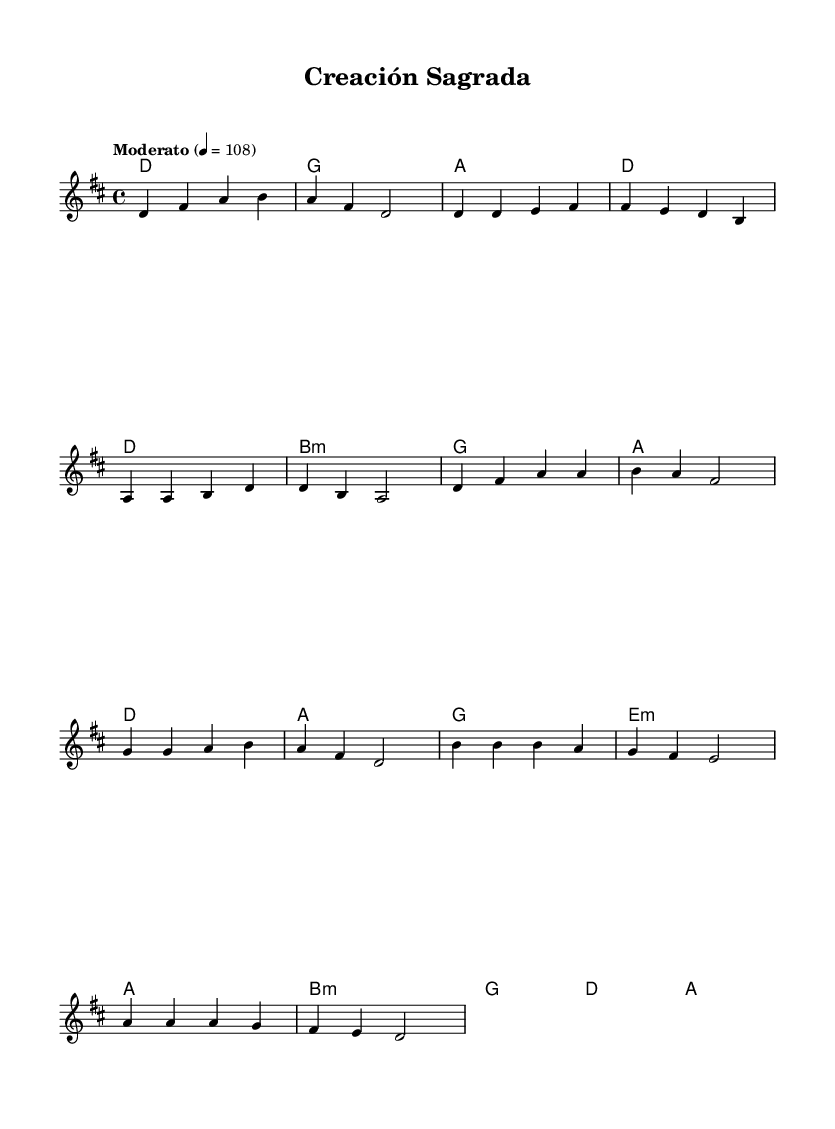What is the key signature of this music? The key signature is D major, which has two sharps (F# and C#). This can be determined from the global settings in the sheet music that indicates the key.
Answer: D major What is the time signature of this music? The time signature is 4/4, meaning there are four beats in each measure and a quarter note receives one beat. This is specified in the global settings of the sheet music.
Answer: 4/4 What is the tempo marking of the piece? The tempo marking indicates "Moderato" at a speed of 108 beats per minute. This can be found in the global settings which provide the tempo indication.
Answer: Moderato 4 = 108 How many measures are in the chorus section? The chorus section consists of 4 measures, as identified in the melody where the specific musical lines for the chorus have been notated.
Answer: 4 Which chord is played during the intro? The chord played during the intro is D major, as seen in the harmonies section that starts with a D chord.
Answer: D What notes comprise the melody of the first measure? The notes in the first measure of the melody are D, F#, A, and B. These notes can be directly counted from the melody line provided at the start of the score.
Answer: D, F#, A, B What type of music is this piece categorized as? This piece is categorized as contemporary Christian rock, which often includes themes of spirituality and environmental consciousness, indicated by its religious context and overall message.
Answer: Contemporary Christian rock 